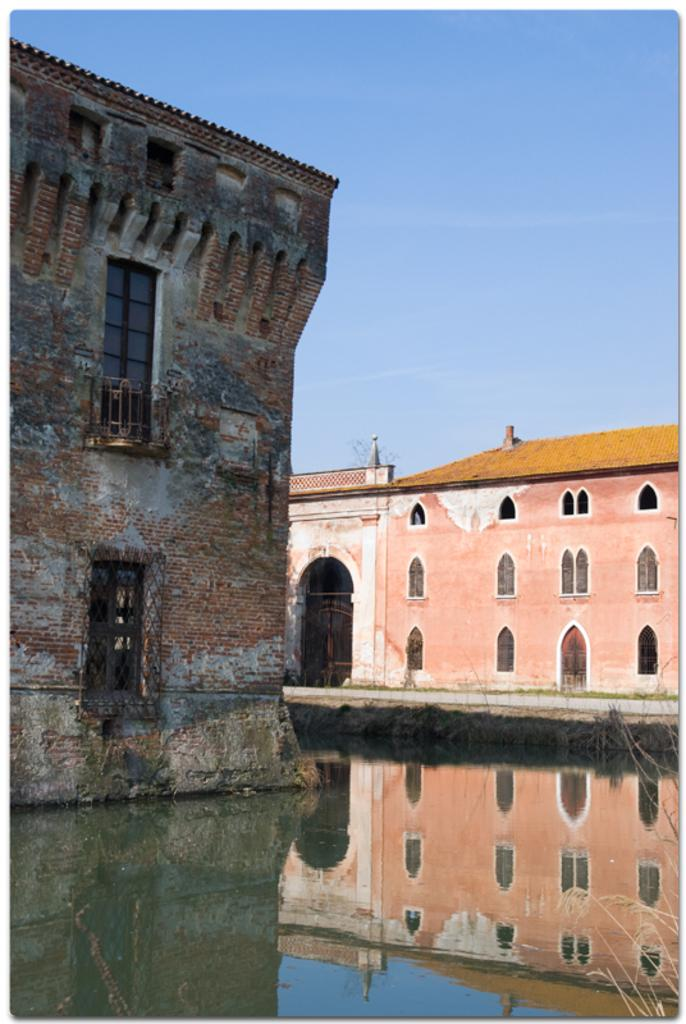What is located at the front of the image? There is water at the front of the image. How many buildings can be seen in the image? There are 2 buildings in the image. What feature do the buildings have? The buildings have windows. Where is the door located in the image? There is a door at the back of one of the buildings. What is visible at the top of the image? The sky is visible at the top of the image. How many bones can be seen in the image? There are no bones present in the image. What are the boys doing in the image? There are no boys present in the image. 